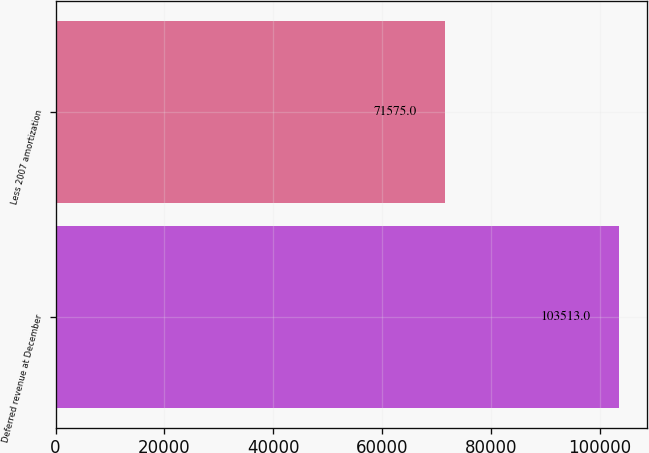Convert chart. <chart><loc_0><loc_0><loc_500><loc_500><bar_chart><fcel>Deferred revenue at December<fcel>Less 2007 amortization<nl><fcel>103513<fcel>71575<nl></chart> 